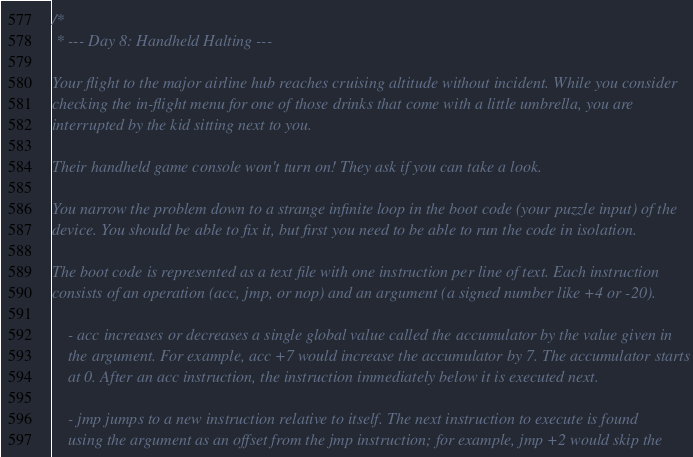<code> <loc_0><loc_0><loc_500><loc_500><_Rust_>/*
 * --- Day 8: Handheld Halting ---

Your flight to the major airline hub reaches cruising altitude without incident. While you consider
checking the in-flight menu for one of those drinks that come with a little umbrella, you are
interrupted by the kid sitting next to you.

Their handheld game console won't turn on! They ask if you can take a look.

You narrow the problem down to a strange infinite loop in the boot code (your puzzle input) of the
device. You should be able to fix it, but first you need to be able to run the code in isolation.

The boot code is represented as a text file with one instruction per line of text. Each instruction
consists of an operation (acc, jmp, or nop) and an argument (a signed number like +4 or -20).

    - acc increases or decreases a single global value called the accumulator by the value given in
    the argument. For example, acc +7 would increase the accumulator by 7. The accumulator starts
    at 0. After an acc instruction, the instruction immediately below it is executed next.

    - jmp jumps to a new instruction relative to itself. The next instruction to execute is found
    using the argument as an offset from the jmp instruction; for example, jmp +2 would skip the</code> 